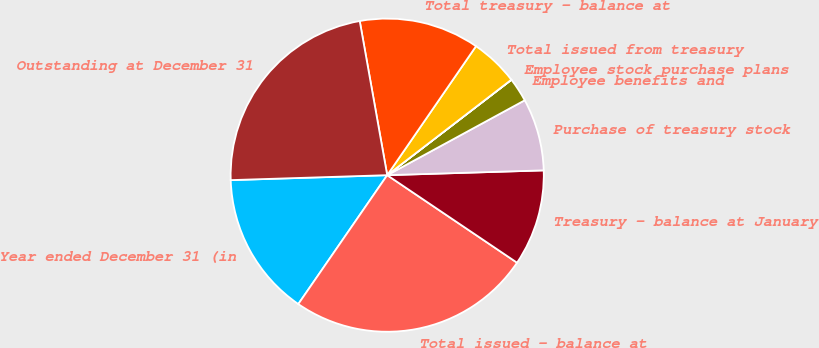Convert chart. <chart><loc_0><loc_0><loc_500><loc_500><pie_chart><fcel>Year ended December 31 (in<fcel>Total issued - balance at<fcel>Treasury - balance at January<fcel>Purchase of treasury stock<fcel>Employee benefits and<fcel>Employee stock purchase plans<fcel>Total issued from treasury<fcel>Total treasury - balance at<fcel>Outstanding at December 31<nl><fcel>14.89%<fcel>25.18%<fcel>9.93%<fcel>7.45%<fcel>2.49%<fcel>0.01%<fcel>4.97%<fcel>12.41%<fcel>22.7%<nl></chart> 